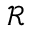Convert formula to latex. <formula><loc_0><loc_0><loc_500><loc_500>\mathcal { R }</formula> 